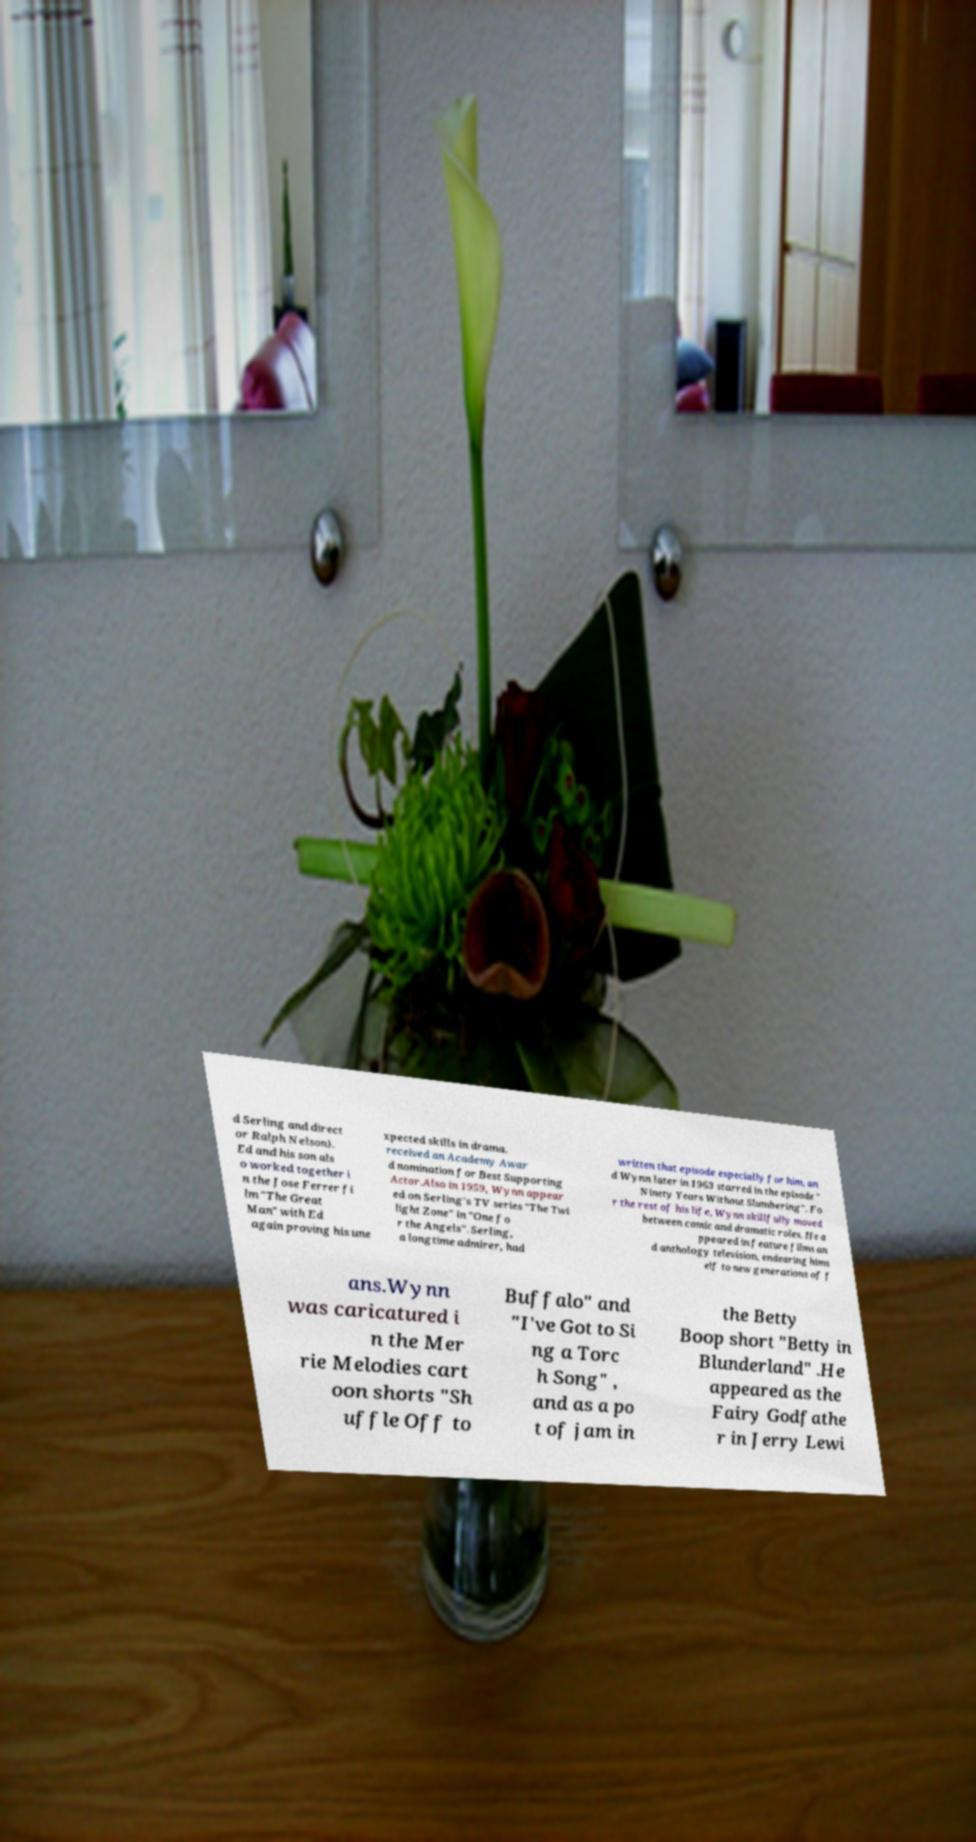Could you assist in decoding the text presented in this image and type it out clearly? d Serling and direct or Ralph Nelson). Ed and his son als o worked together i n the Jose Ferrer fi lm "The Great Man" with Ed again proving his une xpected skills in drama. received an Academy Awar d nomination for Best Supporting Actor.Also in 1959, Wynn appear ed on Serling's TV series "The Twi light Zone" in "One fo r the Angels". Serling, a longtime admirer, had written that episode especially for him, an d Wynn later in 1963 starred in the episode " Ninety Years Without Slumbering". Fo r the rest of his life, Wynn skillfully moved between comic and dramatic roles. He a ppeared in feature films an d anthology television, endearing hims elf to new generations of f ans.Wynn was caricatured i n the Mer rie Melodies cart oon shorts "Sh uffle Off to Buffalo" and "I've Got to Si ng a Torc h Song" , and as a po t of jam in the Betty Boop short "Betty in Blunderland" .He appeared as the Fairy Godfathe r in Jerry Lewi 